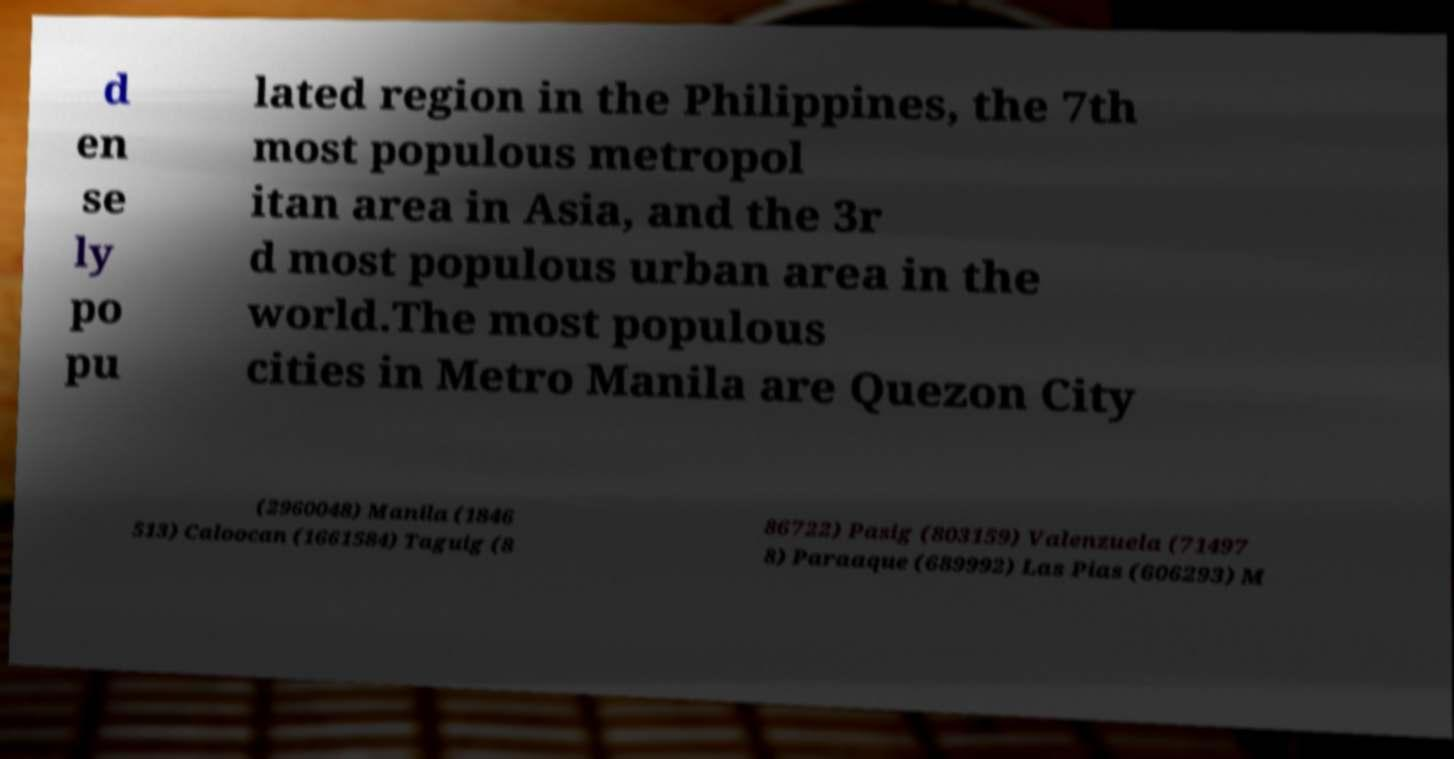Can you accurately transcribe the text from the provided image for me? d en se ly po pu lated region in the Philippines, the 7th most populous metropol itan area in Asia, and the 3r d most populous urban area in the world.The most populous cities in Metro Manila are Quezon City (2960048) Manila (1846 513) Caloocan (1661584) Taguig (8 86722) Pasig (803159) Valenzuela (71497 8) Paraaque (689992) Las Pias (606293) M 